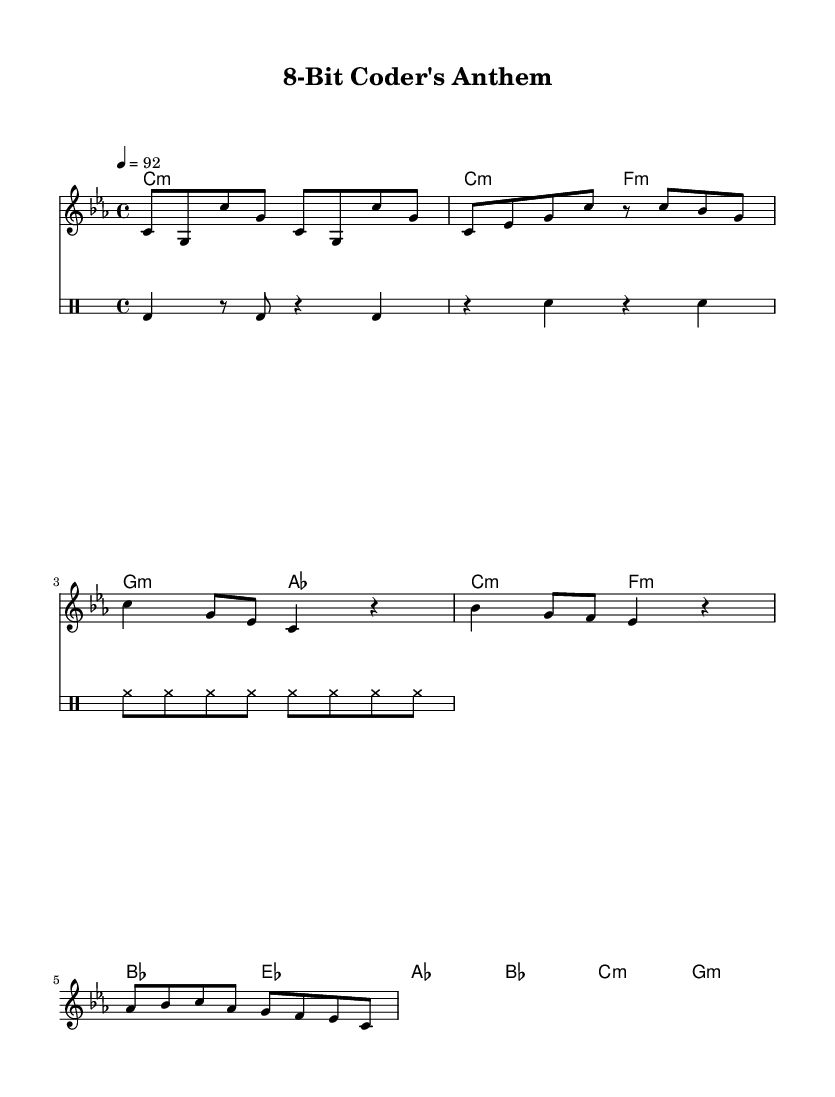What is the key signature of this music? The key signature is indicated at the beginning of the score and consists of three flats, which correspond to C minor.
Answer: C minor What is the time signature of this music? The time signature is found at the beginning of the score, showing four beats in each measure indicated as 4/4.
Answer: 4/4 What is the tempo marking given in the piece? The tempo marking is noted at the beginning in a traditional format, showing 92 beats per minute.
Answer: 92 How many measures are there in the chorus section? By examining the measures specifically labeled as the chorus, we see that there are four main measures comprising this section.
Answer: 4 What is the starting note of the melody? Looking closely at the beginning of the melody line, the first note played is a middle C, as indicated on the staff.
Answer: C Which two instruments are indicated in the score besides the melody? The score illustrates an accompaniment part as well as a dedicated section for drums, distinguishing the harmonic layers present in the piece.
Answer: ChordNames and DrumStaff What is the rhythmic pattern of the drums' kick section? The kick section is analyzed by examining the first few measures of the drum part, revealing a consistent pattern of a bass drum followed by rests and repeated bass notes.
Answer: bass drum pattern is kick and rest 